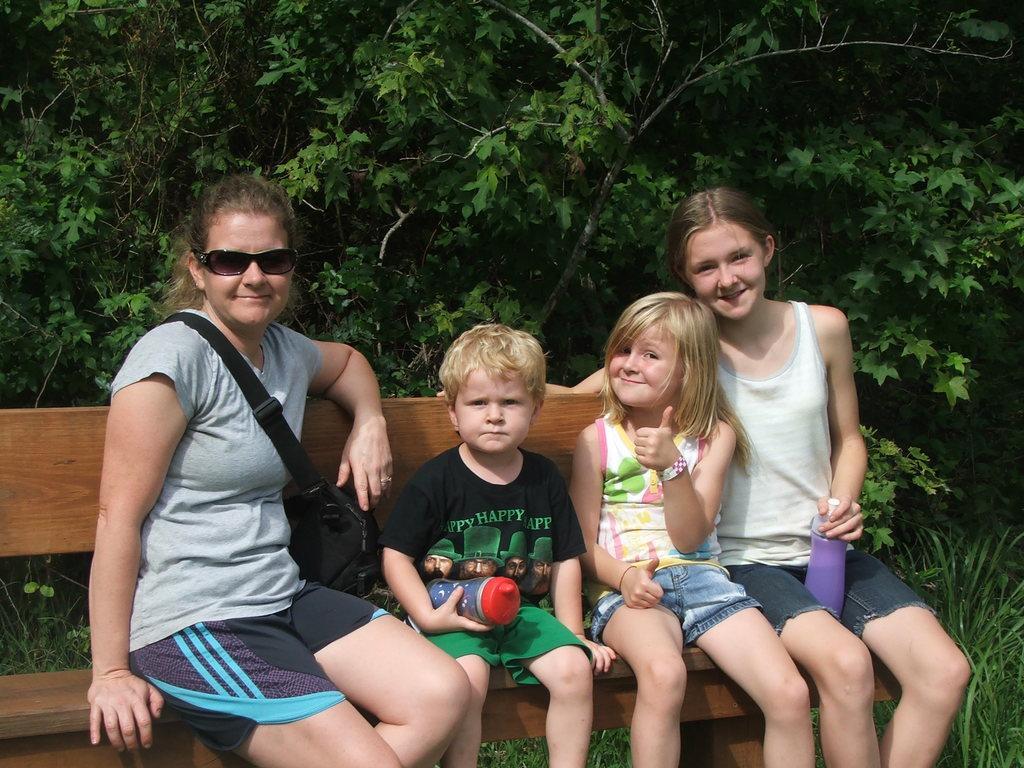Could you give a brief overview of what you see in this image? In this picture I can see trees in the background. I can see a few people sitting on the bench. 